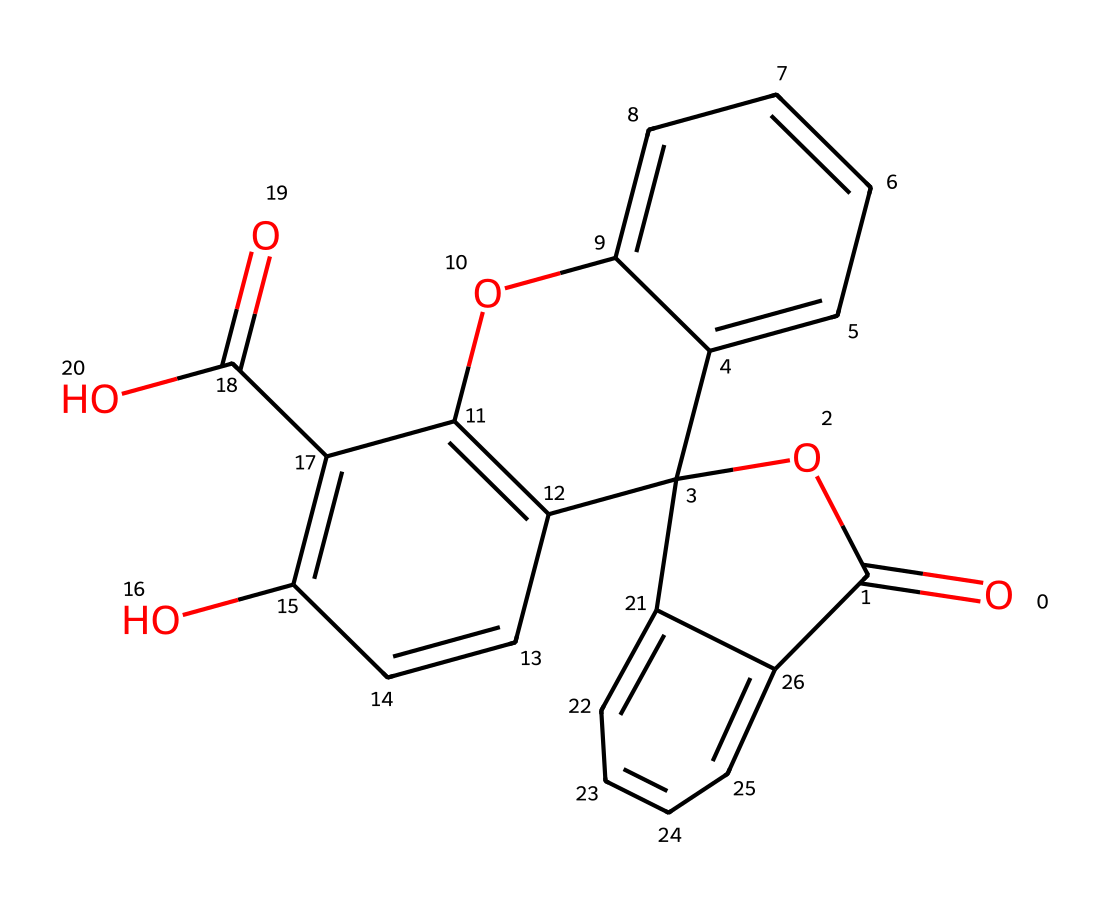What is the molecular formula of fluorescein? To determine the molecular formula from the SMILES representation, we need to identify the individual atoms present. By analyzing the structure, fluorescein contains 22 carbon (C) atoms, 18 hydrogen (H) atoms, 5 oxygen (O) atoms. This gives us the molecular formula C22H18O5.
Answer: C22H18O5 How many rings are present in the chemical structure of fluorescein? The structure contains two fused rings at the center, which are identifiable by their cyclic nature. Additionally, other aromatic rings are present, but the primary count of fused rings in the central structure is two.
Answer: 2 What functional groups are present in fluorescein? By examining the chemical structure, we can identify the functional groups. The molecule has carboxylic acid (-COOH) and ether (-O-) groups. These are indicated by the presence of -COOH near the aromatic rings and the central oxygen atoms connecting rings.
Answer: carboxylic acid and ether Does fluorescein contain any heteroatoms? Heteroatoms refer to any atom that is not carbon or hydrogen. In this molecule, we can see that there are oxygen atoms present, which confirms that there are heteroatoms. Therefore, fluorescein contains heteroatoms.
Answer: Yes What is the primary use of fluorescein in forensic analysis? Fluorescein is primarily used in forensic analysis for visualizing latent fingerprints. Its fluorescent properties allow it to glow under specific lighting conditions, making fingerprints visible for analysis.
Answer: Visualizing latent fingerprints What is the impact of the aromatic rings on the properties of fluorescein? The presence of aromatic rings contributes to the solubility, stability, and fluorescence of the molecule. Aromatic systems often have distinct optical properties due to their electron-rich nature, which enhances fluorescein's ability to absorb and emit light.
Answer: Enhances fluorescence 